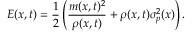Convert formula to latex. <formula><loc_0><loc_0><loc_500><loc_500>E ( x , t ) = \frac { 1 } { 2 } \left ( \frac { m ( x , t ) ^ { 2 } } { \rho ( x , t ) } + \rho ( x , t ) \sigma _ { p } ^ { 2 } ( x ) \right ) .</formula> 